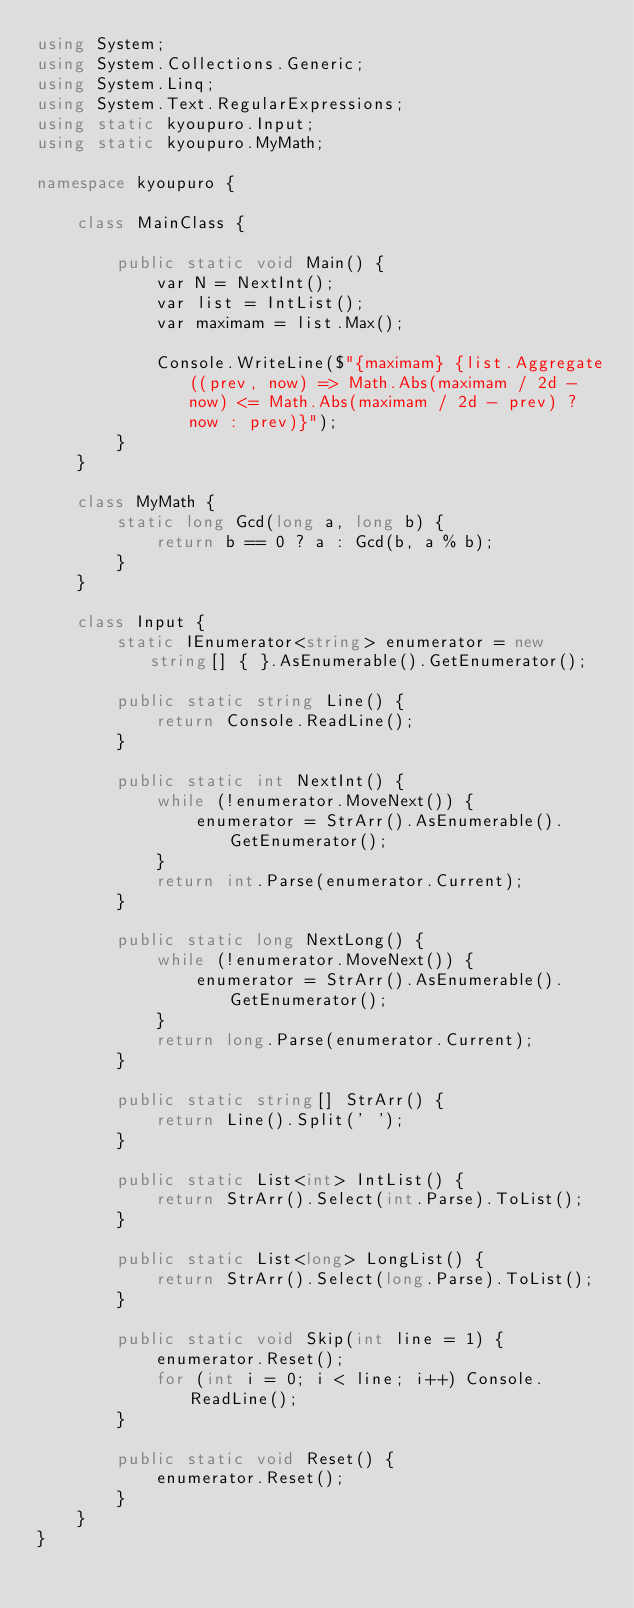<code> <loc_0><loc_0><loc_500><loc_500><_C#_>using System;
using System.Collections.Generic;
using System.Linq;
using System.Text.RegularExpressions;
using static kyoupuro.Input;
using static kyoupuro.MyMath;

namespace kyoupuro {

    class MainClass {

        public static void Main() {
            var N = NextInt();
            var list = IntList();
            var maximam = list.Max();

            Console.WriteLine($"{maximam} {list.Aggregate((prev, now) => Math.Abs(maximam / 2d - now) <= Math.Abs(maximam / 2d - prev) ? now : prev)}");
        }
    }

    class MyMath {
        static long Gcd(long a, long b) {
            return b == 0 ? a : Gcd(b, a % b);
        }
    }

    class Input {
        static IEnumerator<string> enumerator = new string[] { }.AsEnumerable().GetEnumerator();

        public static string Line() {
            return Console.ReadLine();
        }

        public static int NextInt() {
            while (!enumerator.MoveNext()) {
                enumerator = StrArr().AsEnumerable().GetEnumerator();
            }
            return int.Parse(enumerator.Current);
        }

        public static long NextLong() {
            while (!enumerator.MoveNext()) {
                enumerator = StrArr().AsEnumerable().GetEnumerator();
            }
            return long.Parse(enumerator.Current);
        }

        public static string[] StrArr() {
            return Line().Split(' ');
        }

        public static List<int> IntList() {
            return StrArr().Select(int.Parse).ToList();
        }

        public static List<long> LongList() {
            return StrArr().Select(long.Parse).ToList();
        }

        public static void Skip(int line = 1) {
            enumerator.Reset();
            for (int i = 0; i < line; i++) Console.ReadLine();
        }

        public static void Reset() {
            enumerator.Reset();
        }
    }
}</code> 